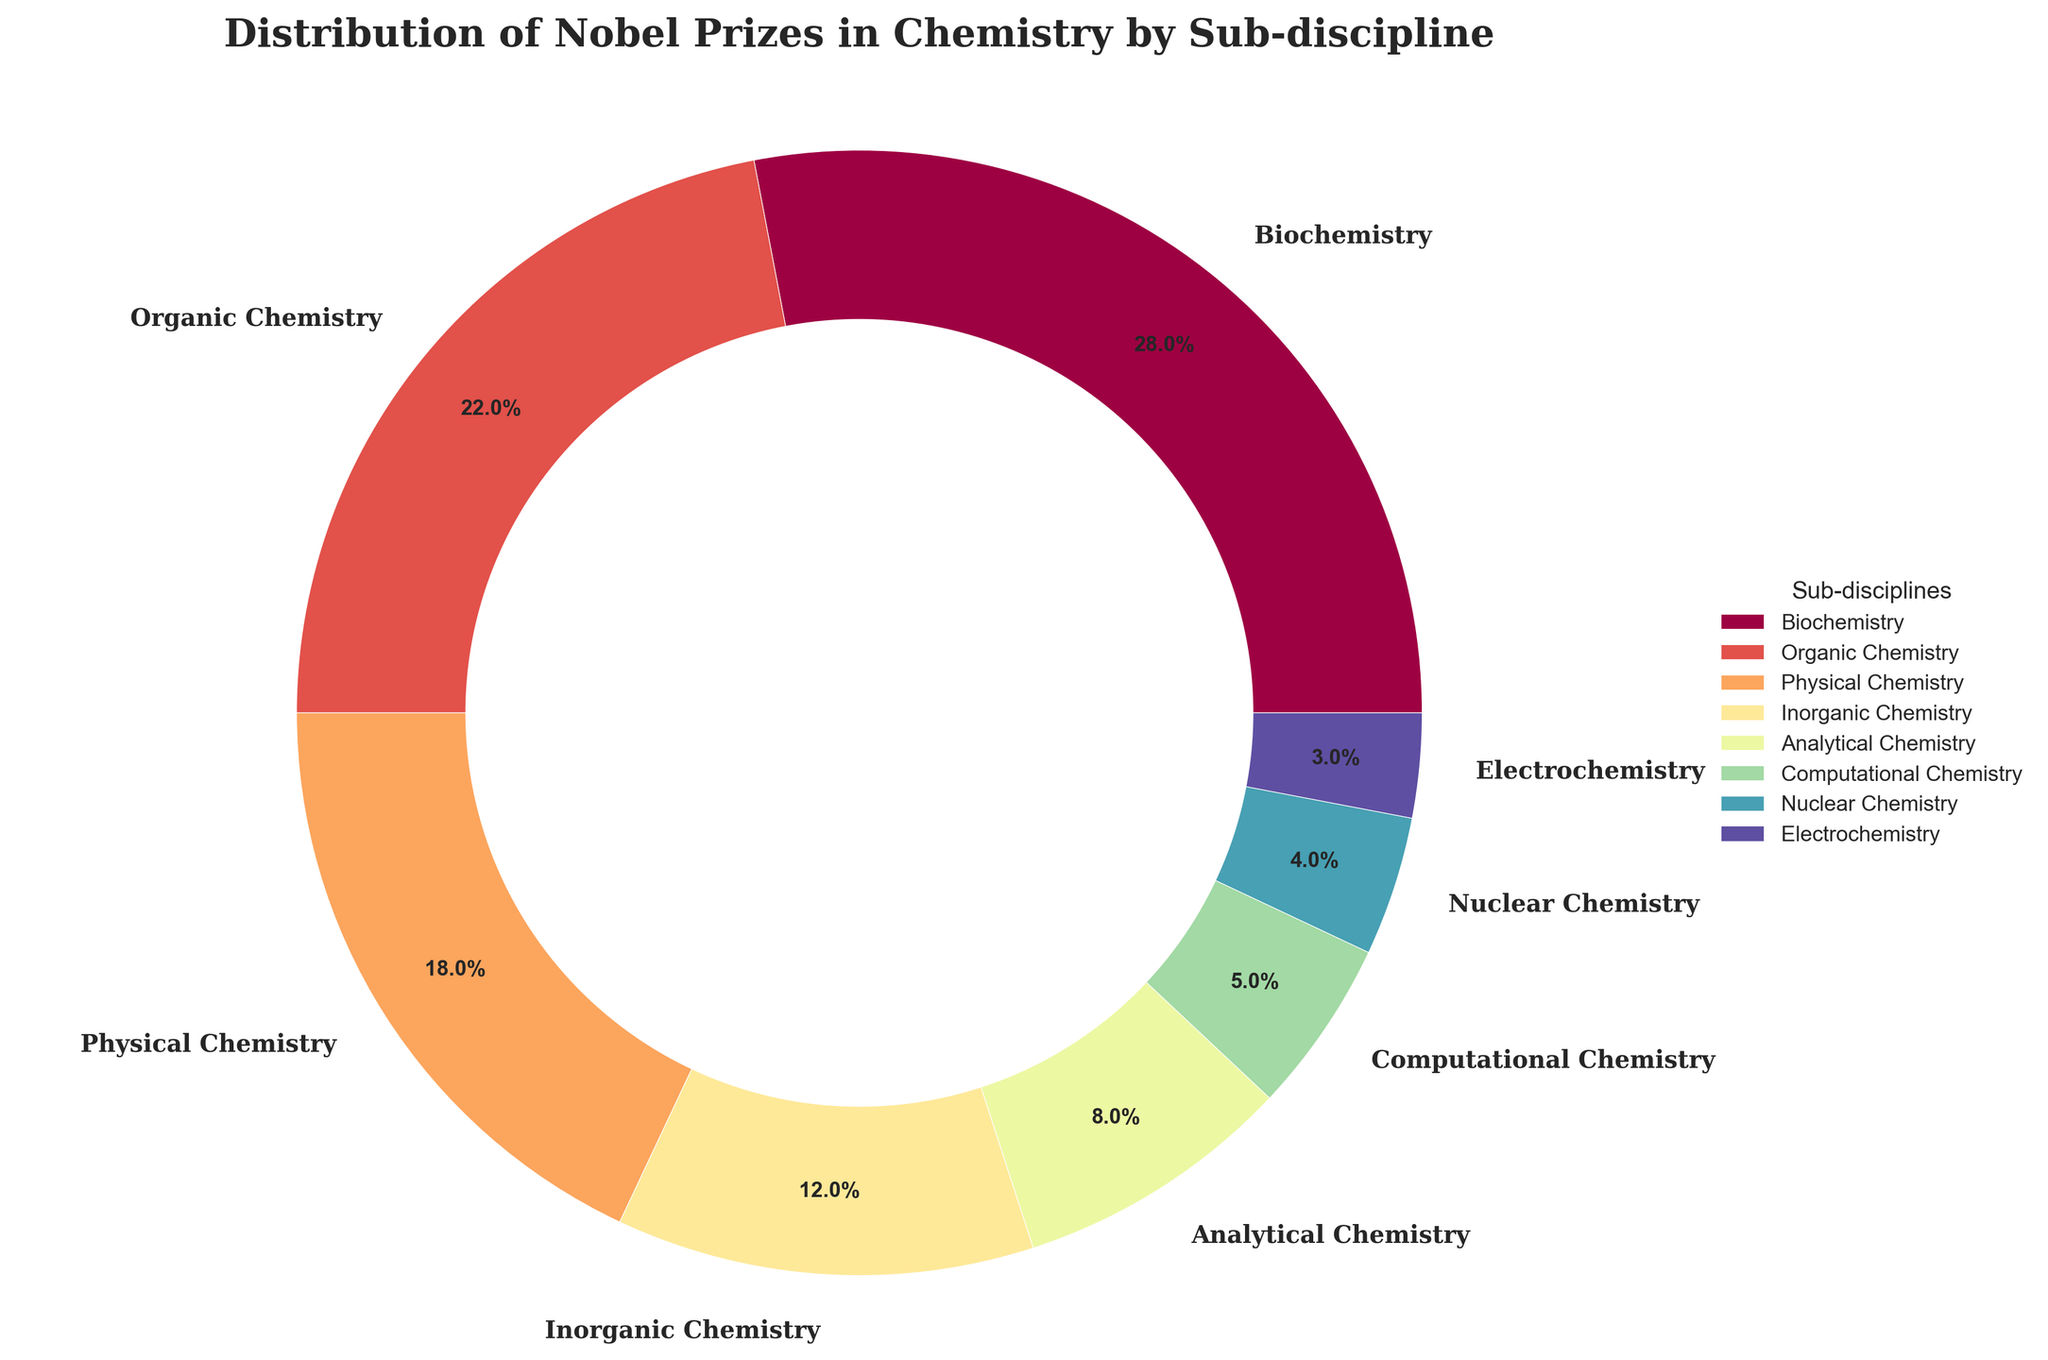Which sub-discipline has the highest number of Nobel Prizes in Chemistry? To answer this question, look for the sub-discipline with the largest slice of the pie. The percentage label will also indicate which has the most significant proportion. Biochemistry has the largest slice with 28%.
Answer: Biochemistry Which sub-discipline has a larger percentage of Nobel Prizes, Organic Chemistry or Physical Chemistry? Look at the slices for Organic Chemistry and Physical Chemistry and compare their percentage labels. Organic Chemistry has 22%, and Physical Chemistry has 18%.
Answer: Organic Chemistry What is the combined percentage of Nobel Prizes awarded in Computational Chemistry and Nuclear Chemistry? Sum the percentages of Computational Chemistry (5%) and Nuclear Chemistry (4%). This requires a simple addition of 5 + 4.
Answer: 9% If you combine Inorganic Chemistry and Electrochemistry, what is their total percentage? Add the percentages of Inorganic Chemistry (12%) and Electrochemistry (3%). Perform the sum 12 + 3.
Answer: 15% What percentage of Nobel Prizes in Chemistry does Analytical Chemistry represent compared to the total percentage of Physical and Organic Chemistry combined? First, calculate the combined percentage of Physical Chemistry and Organic Chemistry (18% + 22% = 40%). Then, compare Analytical Chemistry's percentage (8%) to this total. 8 is less than 40.
Answer: Less Which has a smaller percentage of Nobel Prizes, Inorganic Chemistry or Computational Chemistry? Look at the percentages for both Inorganic Chemistry (12%) and Computational Chemistry (5%). Computational Chemistry has the smaller percentage.
Answer: Computational Chemistry Can you identify the sub-discipline that holds exactly 3% of the Nobel Prizes in Chemistry? Look for the pie slice labeled with 3%. This percentage belongs to Electrochemistry.
Answer: Electrochemistry What is the percentage difference between Biochemistry and Organic Chemistry's Nobel Prize distributions? Subtract the percentage of Organic Chemistry (22%) from Biochemistry (28%). The calculation is 28 - 22.
Answer: 6% Compare the total percentage of Nobel Prizes in Chemistry for sub-disciplines with less than 10% each. Identify the sub-disciplines with less than 10%: Analytical Chemistry (8%), Computational Chemistry (5%), Nuclear Chemistry (4%), and Electrochemistry (3%). Add these together: 8 + 5 + 4 + 3.
Answer: 20% Which sub-discipline has a larger slice in the pie chart, Inorganic Chemistry or Analytical Chemistry? Compare the slices of Inorganic Chemistry (12%) and Analytical Chemistry (8%). The larger slice belongs to Inorganic Chemistry.
Answer: Inorganic Chemistry 